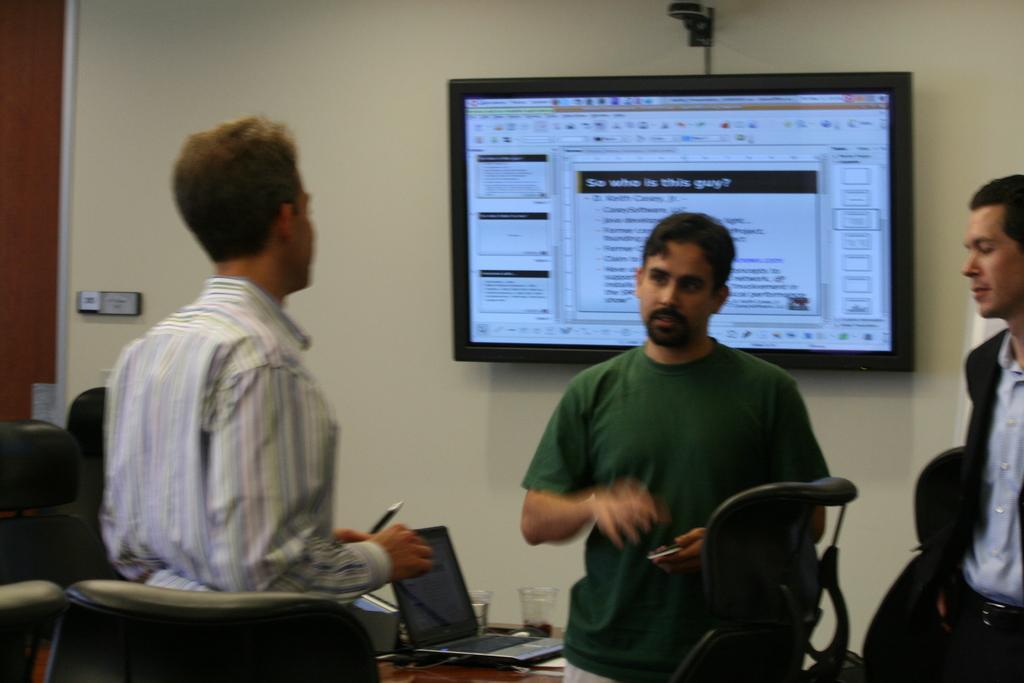How would you summarize this image in a sentence or two? Here in this picture we can see a group o men standing over as place and talking to each other and we can see chairs and tables present and we can see a laptop and glasses present on the table and on the wall we can see a monitor screen with something presented on it. 